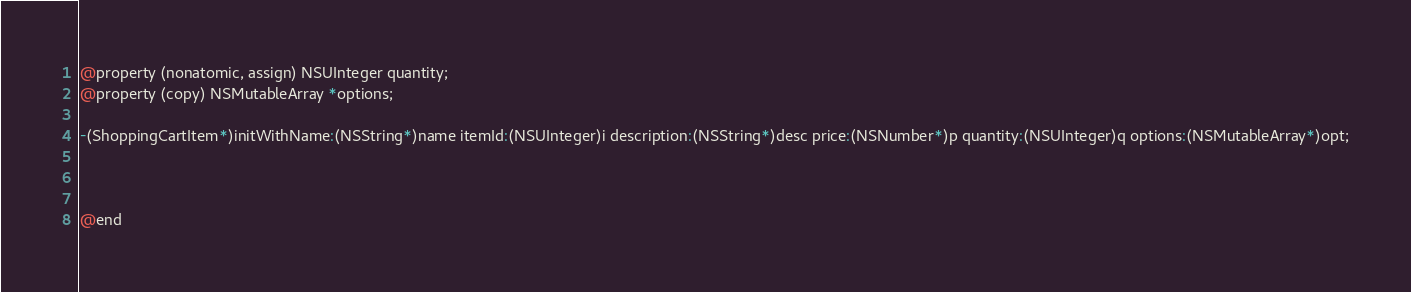<code> <loc_0><loc_0><loc_500><loc_500><_C_>@property (nonatomic, assign) NSUInteger quantity;
@property (copy) NSMutableArray *options;

-(ShoppingCartItem*)initWithName:(NSString*)name itemId:(NSUInteger)i description:(NSString*)desc price:(NSNumber*)p quantity:(NSUInteger)q options:(NSMutableArray*)opt;



@end
</code> 